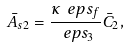<formula> <loc_0><loc_0><loc_500><loc_500>\bar { A } _ { s 2 } = \frac { \kappa \ e p s _ { f } } { \ e p s _ { 3 } } \bar { C } _ { 2 } ,</formula> 